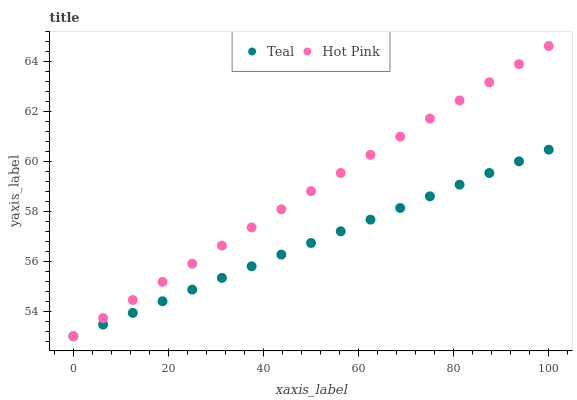Does Teal have the minimum area under the curve?
Answer yes or no. Yes. Does Hot Pink have the maximum area under the curve?
Answer yes or no. Yes. Does Teal have the maximum area under the curve?
Answer yes or no. No. Is Teal the smoothest?
Answer yes or no. Yes. Is Hot Pink the roughest?
Answer yes or no. Yes. Is Teal the roughest?
Answer yes or no. No. Does Hot Pink have the lowest value?
Answer yes or no. Yes. Does Hot Pink have the highest value?
Answer yes or no. Yes. Does Teal have the highest value?
Answer yes or no. No. Does Teal intersect Hot Pink?
Answer yes or no. Yes. Is Teal less than Hot Pink?
Answer yes or no. No. Is Teal greater than Hot Pink?
Answer yes or no. No. 